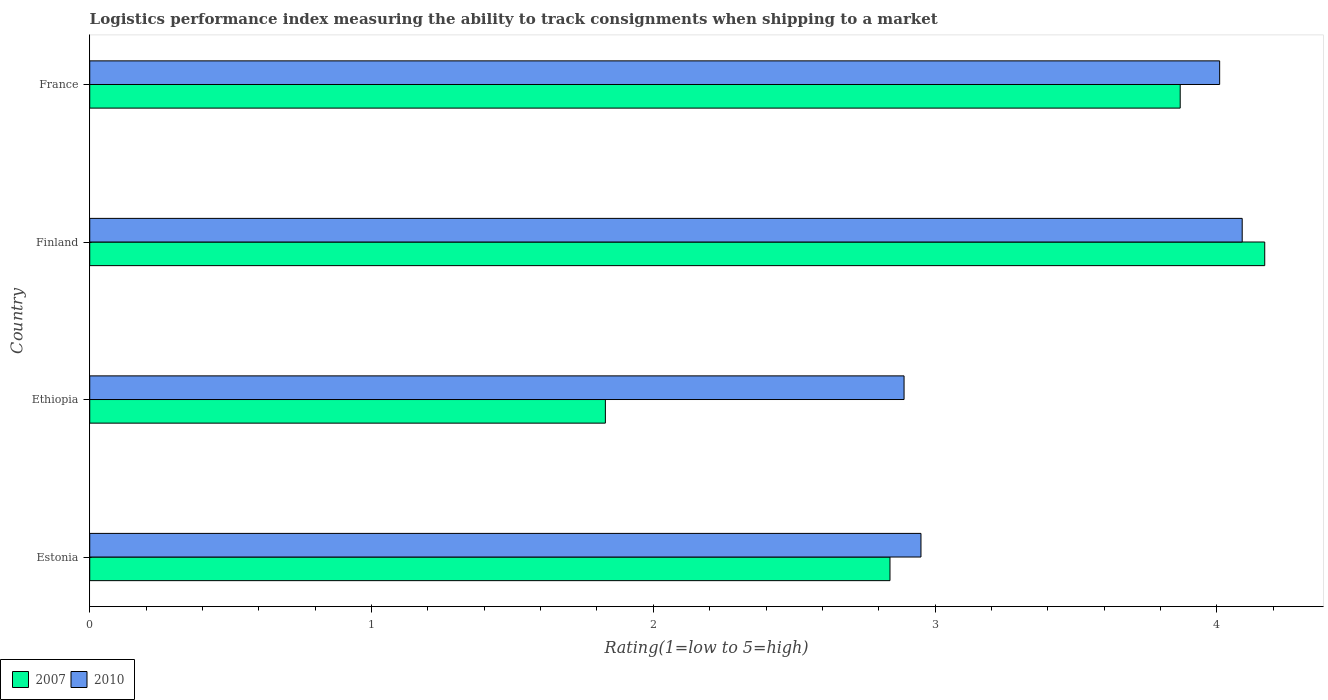Are the number of bars per tick equal to the number of legend labels?
Your response must be concise. Yes. Are the number of bars on each tick of the Y-axis equal?
Your response must be concise. Yes. How many bars are there on the 2nd tick from the bottom?
Give a very brief answer. 2. In how many cases, is the number of bars for a given country not equal to the number of legend labels?
Give a very brief answer. 0. What is the Logistic performance index in 2010 in France?
Offer a very short reply. 4.01. Across all countries, what is the maximum Logistic performance index in 2010?
Provide a succinct answer. 4.09. Across all countries, what is the minimum Logistic performance index in 2010?
Provide a succinct answer. 2.89. In which country was the Logistic performance index in 2007 maximum?
Your answer should be compact. Finland. In which country was the Logistic performance index in 2010 minimum?
Keep it short and to the point. Ethiopia. What is the total Logistic performance index in 2010 in the graph?
Your answer should be compact. 13.94. What is the difference between the Logistic performance index in 2010 in Ethiopia and that in France?
Offer a very short reply. -1.12. What is the difference between the Logistic performance index in 2007 in Estonia and the Logistic performance index in 2010 in France?
Offer a terse response. -1.17. What is the average Logistic performance index in 2007 per country?
Ensure brevity in your answer.  3.18. What is the difference between the Logistic performance index in 2010 and Logistic performance index in 2007 in Estonia?
Keep it short and to the point. 0.11. What is the ratio of the Logistic performance index in 2007 in Estonia to that in Finland?
Your answer should be compact. 0.68. Is the difference between the Logistic performance index in 2010 in Ethiopia and France greater than the difference between the Logistic performance index in 2007 in Ethiopia and France?
Provide a short and direct response. Yes. What is the difference between the highest and the second highest Logistic performance index in 2007?
Ensure brevity in your answer.  0.3. What is the difference between the highest and the lowest Logistic performance index in 2010?
Your answer should be very brief. 1.2. How many bars are there?
Ensure brevity in your answer.  8. Are all the bars in the graph horizontal?
Give a very brief answer. Yes. What is the difference between two consecutive major ticks on the X-axis?
Offer a terse response. 1. Does the graph contain grids?
Make the answer very short. No. How many legend labels are there?
Your answer should be compact. 2. How are the legend labels stacked?
Your answer should be compact. Horizontal. What is the title of the graph?
Offer a very short reply. Logistics performance index measuring the ability to track consignments when shipping to a market. Does "2002" appear as one of the legend labels in the graph?
Provide a succinct answer. No. What is the label or title of the X-axis?
Make the answer very short. Rating(1=low to 5=high). What is the label or title of the Y-axis?
Offer a very short reply. Country. What is the Rating(1=low to 5=high) of 2007 in Estonia?
Provide a succinct answer. 2.84. What is the Rating(1=low to 5=high) in 2010 in Estonia?
Offer a very short reply. 2.95. What is the Rating(1=low to 5=high) in 2007 in Ethiopia?
Offer a very short reply. 1.83. What is the Rating(1=low to 5=high) of 2010 in Ethiopia?
Provide a succinct answer. 2.89. What is the Rating(1=low to 5=high) in 2007 in Finland?
Make the answer very short. 4.17. What is the Rating(1=low to 5=high) in 2010 in Finland?
Offer a very short reply. 4.09. What is the Rating(1=low to 5=high) of 2007 in France?
Offer a very short reply. 3.87. What is the Rating(1=low to 5=high) of 2010 in France?
Your response must be concise. 4.01. Across all countries, what is the maximum Rating(1=low to 5=high) of 2007?
Your answer should be very brief. 4.17. Across all countries, what is the maximum Rating(1=low to 5=high) of 2010?
Give a very brief answer. 4.09. Across all countries, what is the minimum Rating(1=low to 5=high) in 2007?
Ensure brevity in your answer.  1.83. Across all countries, what is the minimum Rating(1=low to 5=high) of 2010?
Your answer should be compact. 2.89. What is the total Rating(1=low to 5=high) in 2007 in the graph?
Make the answer very short. 12.71. What is the total Rating(1=low to 5=high) in 2010 in the graph?
Ensure brevity in your answer.  13.94. What is the difference between the Rating(1=low to 5=high) of 2010 in Estonia and that in Ethiopia?
Your answer should be compact. 0.06. What is the difference between the Rating(1=low to 5=high) in 2007 in Estonia and that in Finland?
Your answer should be compact. -1.33. What is the difference between the Rating(1=low to 5=high) in 2010 in Estonia and that in Finland?
Provide a short and direct response. -1.14. What is the difference between the Rating(1=low to 5=high) of 2007 in Estonia and that in France?
Offer a terse response. -1.03. What is the difference between the Rating(1=low to 5=high) of 2010 in Estonia and that in France?
Your answer should be very brief. -1.06. What is the difference between the Rating(1=low to 5=high) in 2007 in Ethiopia and that in Finland?
Ensure brevity in your answer.  -2.34. What is the difference between the Rating(1=low to 5=high) of 2010 in Ethiopia and that in Finland?
Offer a terse response. -1.2. What is the difference between the Rating(1=low to 5=high) in 2007 in Ethiopia and that in France?
Your answer should be compact. -2.04. What is the difference between the Rating(1=low to 5=high) of 2010 in Ethiopia and that in France?
Give a very brief answer. -1.12. What is the difference between the Rating(1=low to 5=high) of 2010 in Finland and that in France?
Offer a terse response. 0.08. What is the difference between the Rating(1=low to 5=high) in 2007 in Estonia and the Rating(1=low to 5=high) in 2010 in Ethiopia?
Ensure brevity in your answer.  -0.05. What is the difference between the Rating(1=low to 5=high) in 2007 in Estonia and the Rating(1=low to 5=high) in 2010 in Finland?
Your response must be concise. -1.25. What is the difference between the Rating(1=low to 5=high) in 2007 in Estonia and the Rating(1=low to 5=high) in 2010 in France?
Keep it short and to the point. -1.17. What is the difference between the Rating(1=low to 5=high) in 2007 in Ethiopia and the Rating(1=low to 5=high) in 2010 in Finland?
Give a very brief answer. -2.26. What is the difference between the Rating(1=low to 5=high) of 2007 in Ethiopia and the Rating(1=low to 5=high) of 2010 in France?
Provide a succinct answer. -2.18. What is the difference between the Rating(1=low to 5=high) in 2007 in Finland and the Rating(1=low to 5=high) in 2010 in France?
Offer a terse response. 0.16. What is the average Rating(1=low to 5=high) in 2007 per country?
Your response must be concise. 3.18. What is the average Rating(1=low to 5=high) of 2010 per country?
Ensure brevity in your answer.  3.48. What is the difference between the Rating(1=low to 5=high) in 2007 and Rating(1=low to 5=high) in 2010 in Estonia?
Your answer should be compact. -0.11. What is the difference between the Rating(1=low to 5=high) of 2007 and Rating(1=low to 5=high) of 2010 in Ethiopia?
Keep it short and to the point. -1.06. What is the difference between the Rating(1=low to 5=high) in 2007 and Rating(1=low to 5=high) in 2010 in France?
Your response must be concise. -0.14. What is the ratio of the Rating(1=low to 5=high) of 2007 in Estonia to that in Ethiopia?
Offer a terse response. 1.55. What is the ratio of the Rating(1=low to 5=high) of 2010 in Estonia to that in Ethiopia?
Your answer should be compact. 1.02. What is the ratio of the Rating(1=low to 5=high) of 2007 in Estonia to that in Finland?
Offer a very short reply. 0.68. What is the ratio of the Rating(1=low to 5=high) in 2010 in Estonia to that in Finland?
Provide a succinct answer. 0.72. What is the ratio of the Rating(1=low to 5=high) in 2007 in Estonia to that in France?
Ensure brevity in your answer.  0.73. What is the ratio of the Rating(1=low to 5=high) of 2010 in Estonia to that in France?
Your answer should be very brief. 0.74. What is the ratio of the Rating(1=low to 5=high) of 2007 in Ethiopia to that in Finland?
Your answer should be very brief. 0.44. What is the ratio of the Rating(1=low to 5=high) in 2010 in Ethiopia to that in Finland?
Provide a succinct answer. 0.71. What is the ratio of the Rating(1=low to 5=high) of 2007 in Ethiopia to that in France?
Your answer should be very brief. 0.47. What is the ratio of the Rating(1=low to 5=high) in 2010 in Ethiopia to that in France?
Your answer should be very brief. 0.72. What is the ratio of the Rating(1=low to 5=high) of 2007 in Finland to that in France?
Give a very brief answer. 1.08. What is the difference between the highest and the second highest Rating(1=low to 5=high) of 2010?
Offer a terse response. 0.08. What is the difference between the highest and the lowest Rating(1=low to 5=high) in 2007?
Ensure brevity in your answer.  2.34. 